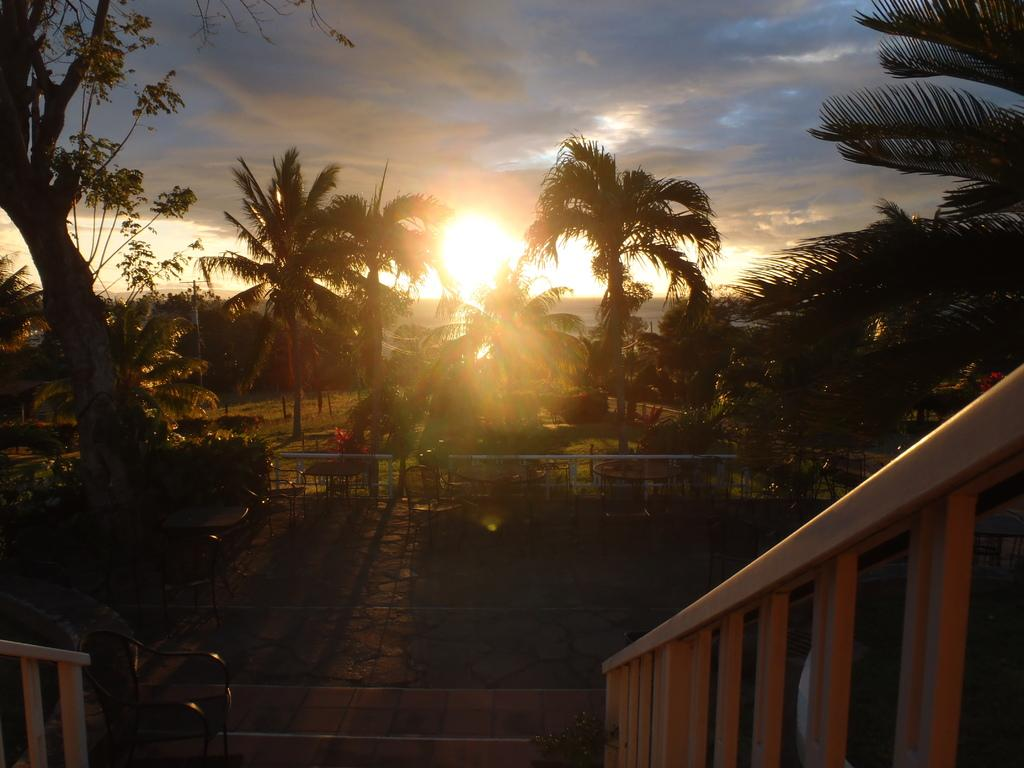What type of natural elements can be seen in the image? There are trees and plants in the image. What type of furniture is present in the image? There are tables and chairs in the image. What architectural feature can be seen in the image? There are wooden staircase holders in the image. What is visible in the sky in the image? There are clouds and the sun visible in the sky. What type of scissors are being used to cut the cream in the image? There is no scissors or cream present in the image. What color is the curtain hanging near the wooden staircase holders in the image? There is no curtain visible in the image; only trees, plants, tables, chairs, wooden staircase holders, clouds, and the sun are present. 